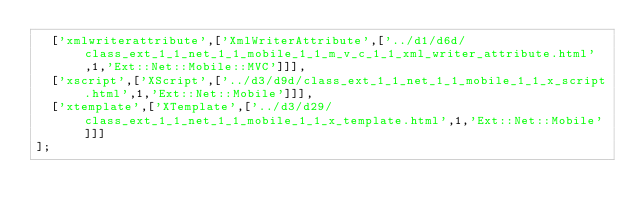Convert code to text. <code><loc_0><loc_0><loc_500><loc_500><_JavaScript_>  ['xmlwriterattribute',['XmlWriterAttribute',['../d1/d6d/class_ext_1_1_net_1_1_mobile_1_1_m_v_c_1_1_xml_writer_attribute.html',1,'Ext::Net::Mobile::MVC']]],
  ['xscript',['XScript',['../d3/d9d/class_ext_1_1_net_1_1_mobile_1_1_x_script.html',1,'Ext::Net::Mobile']]],
  ['xtemplate',['XTemplate',['../d3/d29/class_ext_1_1_net_1_1_mobile_1_1_x_template.html',1,'Ext::Net::Mobile']]]
];
</code> 